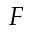Convert formula to latex. <formula><loc_0><loc_0><loc_500><loc_500>F</formula> 